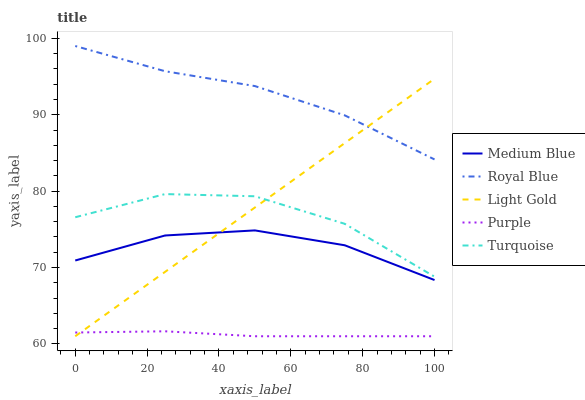Does Turquoise have the minimum area under the curve?
Answer yes or no. No. Does Turquoise have the maximum area under the curve?
Answer yes or no. No. Is Royal Blue the smoothest?
Answer yes or no. No. Is Royal Blue the roughest?
Answer yes or no. No. Does Turquoise have the lowest value?
Answer yes or no. No. Does Turquoise have the highest value?
Answer yes or no. No. Is Medium Blue less than Royal Blue?
Answer yes or no. Yes. Is Royal Blue greater than Purple?
Answer yes or no. Yes. Does Medium Blue intersect Royal Blue?
Answer yes or no. No. 